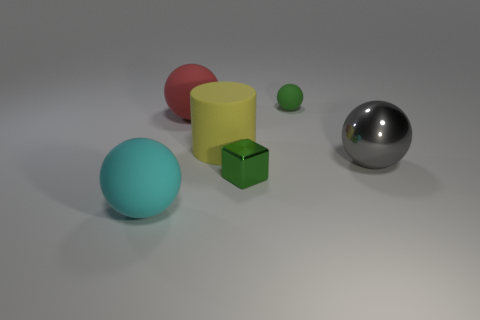What number of matte things are big balls or cylinders?
Offer a very short reply. 3. The large yellow object has what shape?
Keep it short and to the point. Cylinder. Are the tiny green cube and the big cyan thing made of the same material?
Keep it short and to the point. No. Are there any rubber cylinders that are behind the big thing on the left side of the large rubber sphere behind the yellow rubber object?
Your answer should be compact. Yes. What number of other things are the same shape as the small shiny object?
Offer a very short reply. 0. What shape is the object that is to the right of the small metal thing and in front of the green matte sphere?
Your answer should be compact. Sphere. There is a thing that is in front of the tiny object in front of the big rubber sphere that is behind the cylinder; what is its color?
Keep it short and to the point. Cyan. Is the number of green blocks that are to the left of the big cyan rubber object greater than the number of big red spheres that are to the right of the red matte thing?
Your answer should be compact. No. How many other things are there of the same size as the rubber cylinder?
Provide a short and direct response. 3. What size is the sphere that is the same color as the small metal object?
Keep it short and to the point. Small. 